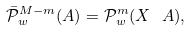Convert formula to latex. <formula><loc_0><loc_0><loc_500><loc_500>\bar { \mathcal { P } } _ { w } ^ { M - m } ( A ) = \mathcal { P } _ { w } ^ { m } ( X \ A ) ,</formula> 